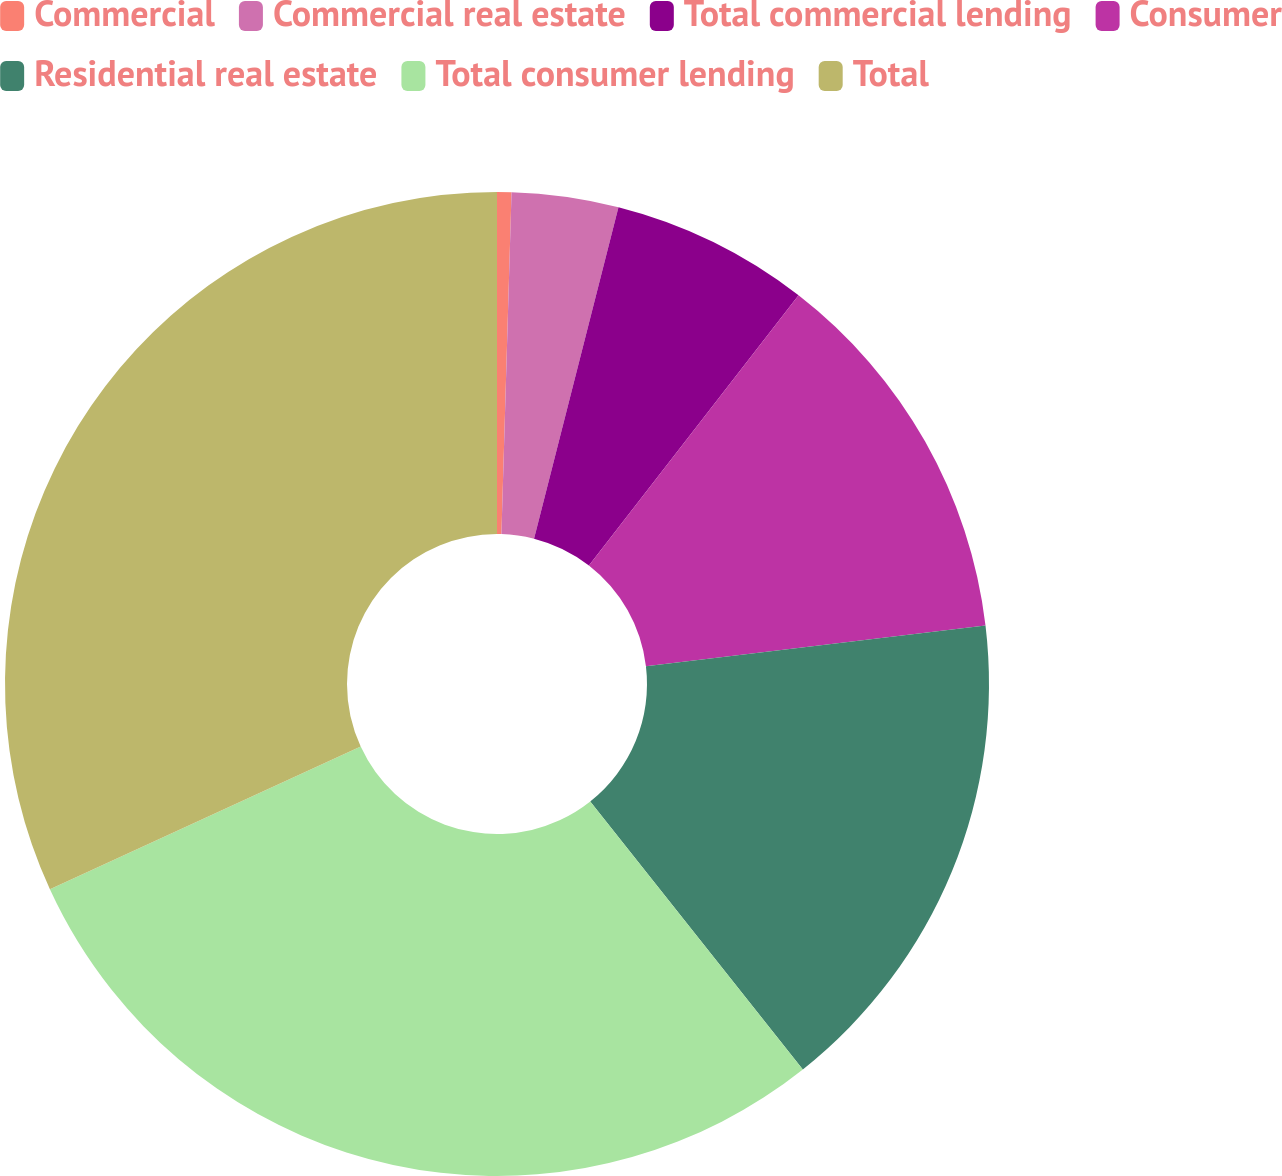Convert chart. <chart><loc_0><loc_0><loc_500><loc_500><pie_chart><fcel>Commercial<fcel>Commercial real estate<fcel>Total commercial lending<fcel>Consumer<fcel>Residential real estate<fcel>Total consumer lending<fcel>Total<nl><fcel>0.47%<fcel>3.5%<fcel>6.53%<fcel>12.6%<fcel>16.22%<fcel>28.82%<fcel>31.85%<nl></chart> 